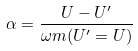Convert formula to latex. <formula><loc_0><loc_0><loc_500><loc_500>\alpha = \frac { U - U ^ { \prime } } { \omega m ( U ^ { \prime } = U ) }</formula> 